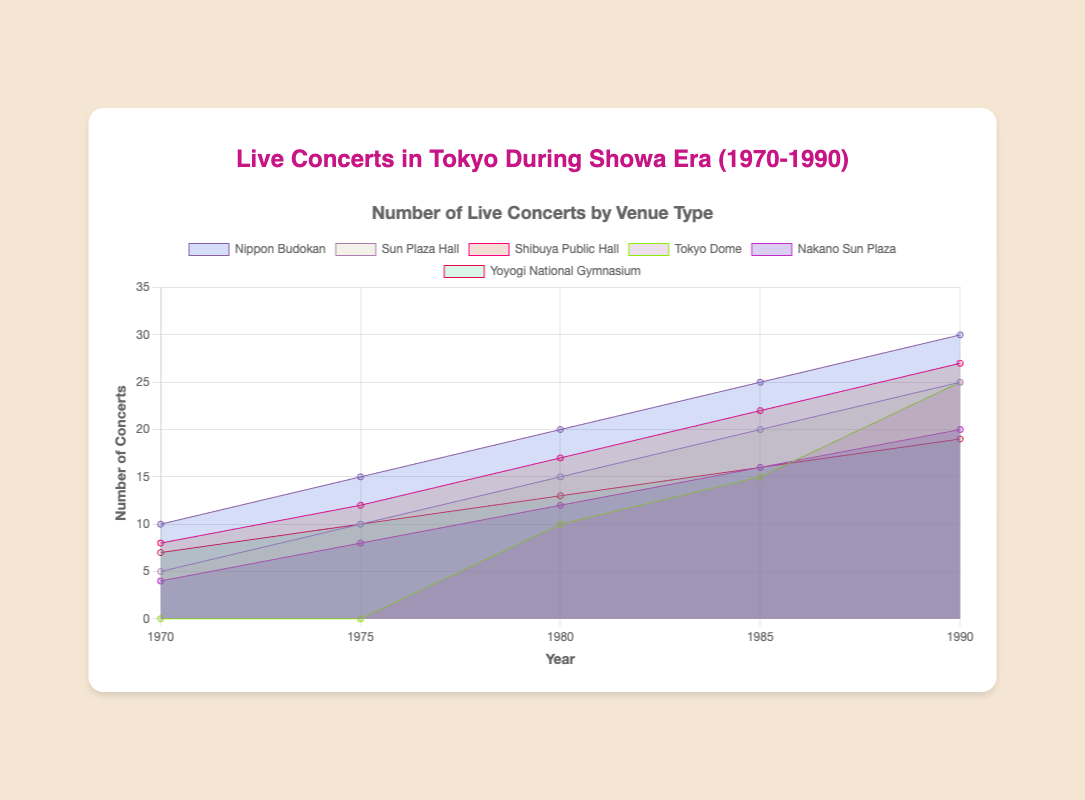What is the title of the figure? The title is at the top of the figure and provides an overview of what the chart is about.
Answer: Live Concerts in Tokyo During Showa Era (1970-1990) Which venue had the highest number of concerts by 1990? To find this, compare the data points for all venues in 1990. The highest value shown in that year is for Nippon Budokan with 30 concerts.
Answer: Nippon Budokan How many concerts were held at Tokyo Dome in 1980? Look at the data point for Tokyo Dome in the year 1980 on the chart. The value is 10.
Answer: 10 What was the total number of concerts held across all venues in 1985? Sum up the values for all venues in the year 1985. Nippon Budokan (25) + Sun Plaza Hall (20) + Shibuya Public Hall (22) + Tokyo Dome (15) + Nakano Sun Plaza (16) + Yoyogi National Gymnasium (16) = 114.
Answer: 114 Which venue showed the most gradual increase in concerts over the period? Analyze the slope of the lines representing each venue from 1970 to 1990. Nakano Sun Plaza shows a steady and gradual increase.
Answer: Nakano Sun Plaza Between which years did Nippon Budokan see the highest increase in the number of concerts? Calculate the difference in the number of concerts between consecutive years for Nippon Budokan. The highest increase is from 1985 to 1990 (30 - 25 = 5).
Answer: 1985 to 1990 In which year did Shibuya Public Hall surpass Sun Plaza Hall in the number of concerts? Compare the values for Shibuya Public Hall and Sun Plaza Hall for each year. Shibuya Public Hall surpassed Sun Plaza Hall in 1980 (17 > 15).
Answer: 1980 What is the average number of concerts held at Nakano Sun Plaza from 1970 to 1990? Add the values for Nakano Sun Plaza from 1970 to 1990 and divide by the number of data points. (4 + 8 + 12 + 16 + 20) / 5 = 12.
Answer: 12 Which venue hosted zero concerts at the start of the period but had an increase by the end? Look for a venue with a value of 0 in 1970 and increasing values in later years; Tokyo Dome fits this criterion.
Answer: Tokyo Dome Between which consecutive years did Yoyogi National Gymnasium see the smallest increase in concerts? Calculate the increase in concerts for Yoyogi National Gymnasium between each consecutive year period. The smallest increase is from 1975 to 1980 (13 - 10 = 3).
Answer: 1975 to 1980 